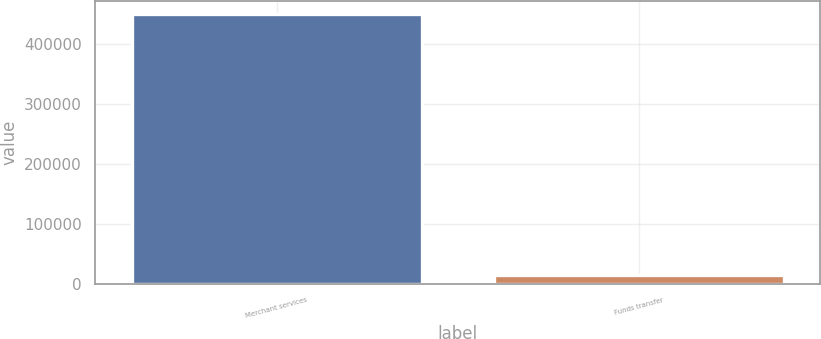<chart> <loc_0><loc_0><loc_500><loc_500><bar_chart><fcel>Merchant services<fcel>Funds transfer<nl><fcel>449144<fcel>13682<nl></chart> 